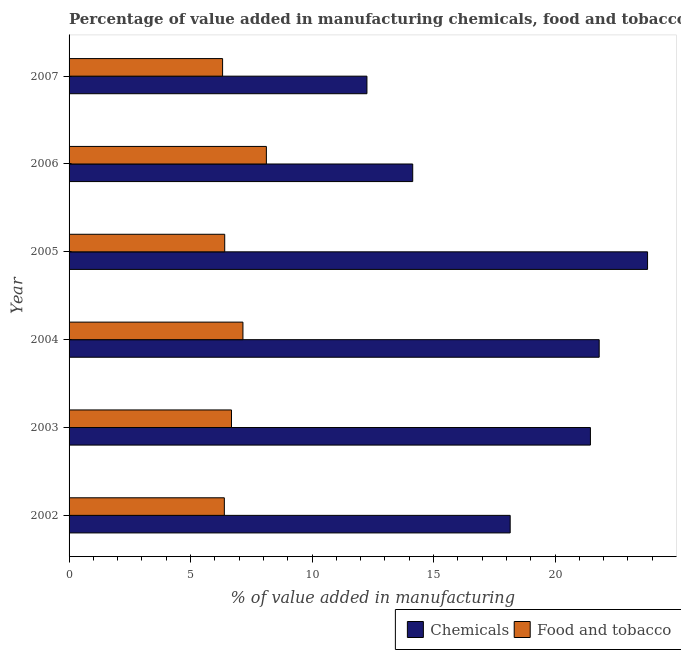How many different coloured bars are there?
Your response must be concise. 2. How many groups of bars are there?
Offer a very short reply. 6. Are the number of bars per tick equal to the number of legend labels?
Keep it short and to the point. Yes. What is the value added by manufacturing food and tobacco in 2006?
Ensure brevity in your answer.  8.12. Across all years, what is the maximum value added by manufacturing food and tobacco?
Your answer should be compact. 8.12. Across all years, what is the minimum value added by manufacturing food and tobacco?
Offer a terse response. 6.32. In which year was the value added by manufacturing food and tobacco minimum?
Offer a terse response. 2007. What is the total value added by manufacturing food and tobacco in the graph?
Your answer should be very brief. 41.07. What is the difference between the value added by manufacturing food and tobacco in 2005 and that in 2007?
Offer a terse response. 0.09. What is the difference between the value added by manufacturing food and tobacco in 2005 and the value added by  manufacturing chemicals in 2003?
Make the answer very short. -15.05. What is the average value added by manufacturing food and tobacco per year?
Provide a succinct answer. 6.84. In the year 2004, what is the difference between the value added by  manufacturing chemicals and value added by manufacturing food and tobacco?
Ensure brevity in your answer.  14.66. What is the ratio of the value added by manufacturing food and tobacco in 2002 to that in 2003?
Offer a very short reply. 0.96. Is the value added by manufacturing food and tobacco in 2002 less than that in 2006?
Make the answer very short. Yes. Is the difference between the value added by  manufacturing chemicals in 2002 and 2006 greater than the difference between the value added by manufacturing food and tobacco in 2002 and 2006?
Make the answer very short. Yes. What is the difference between the highest and the second highest value added by  manufacturing chemicals?
Give a very brief answer. 1.99. What is the difference between the highest and the lowest value added by  manufacturing chemicals?
Your response must be concise. 11.55. In how many years, is the value added by  manufacturing chemicals greater than the average value added by  manufacturing chemicals taken over all years?
Your answer should be very brief. 3. Is the sum of the value added by manufacturing food and tobacco in 2003 and 2004 greater than the maximum value added by  manufacturing chemicals across all years?
Your answer should be compact. No. What does the 1st bar from the top in 2005 represents?
Your answer should be very brief. Food and tobacco. What does the 2nd bar from the bottom in 2006 represents?
Your response must be concise. Food and tobacco. How many bars are there?
Make the answer very short. 12. How many years are there in the graph?
Give a very brief answer. 6. Does the graph contain grids?
Keep it short and to the point. No. Where does the legend appear in the graph?
Keep it short and to the point. Bottom right. What is the title of the graph?
Make the answer very short. Percentage of value added in manufacturing chemicals, food and tobacco in Bahrain. Does "Technicians" appear as one of the legend labels in the graph?
Make the answer very short. No. What is the label or title of the X-axis?
Your answer should be compact. % of value added in manufacturing. What is the % of value added in manufacturing in Chemicals in 2002?
Your response must be concise. 18.15. What is the % of value added in manufacturing of Food and tobacco in 2002?
Provide a short and direct response. 6.39. What is the % of value added in manufacturing in Chemicals in 2003?
Make the answer very short. 21.46. What is the % of value added in manufacturing in Food and tobacco in 2003?
Your response must be concise. 6.68. What is the % of value added in manufacturing of Chemicals in 2004?
Offer a terse response. 21.82. What is the % of value added in manufacturing in Food and tobacco in 2004?
Make the answer very short. 7.16. What is the % of value added in manufacturing in Chemicals in 2005?
Provide a succinct answer. 23.81. What is the % of value added in manufacturing in Food and tobacco in 2005?
Offer a terse response. 6.41. What is the % of value added in manufacturing in Chemicals in 2006?
Give a very brief answer. 14.14. What is the % of value added in manufacturing in Food and tobacco in 2006?
Ensure brevity in your answer.  8.12. What is the % of value added in manufacturing of Chemicals in 2007?
Ensure brevity in your answer.  12.26. What is the % of value added in manufacturing in Food and tobacco in 2007?
Offer a terse response. 6.32. Across all years, what is the maximum % of value added in manufacturing in Chemicals?
Offer a terse response. 23.81. Across all years, what is the maximum % of value added in manufacturing in Food and tobacco?
Your answer should be very brief. 8.12. Across all years, what is the minimum % of value added in manufacturing in Chemicals?
Your answer should be very brief. 12.26. Across all years, what is the minimum % of value added in manufacturing in Food and tobacco?
Your answer should be compact. 6.32. What is the total % of value added in manufacturing of Chemicals in the graph?
Give a very brief answer. 111.63. What is the total % of value added in manufacturing of Food and tobacco in the graph?
Your answer should be compact. 41.07. What is the difference between the % of value added in manufacturing of Chemicals in 2002 and that in 2003?
Provide a short and direct response. -3.3. What is the difference between the % of value added in manufacturing of Food and tobacco in 2002 and that in 2003?
Make the answer very short. -0.29. What is the difference between the % of value added in manufacturing of Chemicals in 2002 and that in 2004?
Ensure brevity in your answer.  -3.66. What is the difference between the % of value added in manufacturing in Food and tobacco in 2002 and that in 2004?
Offer a very short reply. -0.77. What is the difference between the % of value added in manufacturing in Chemicals in 2002 and that in 2005?
Give a very brief answer. -5.65. What is the difference between the % of value added in manufacturing of Food and tobacco in 2002 and that in 2005?
Your response must be concise. -0.01. What is the difference between the % of value added in manufacturing of Chemicals in 2002 and that in 2006?
Provide a short and direct response. 4.01. What is the difference between the % of value added in manufacturing in Food and tobacco in 2002 and that in 2006?
Your answer should be very brief. -1.73. What is the difference between the % of value added in manufacturing of Chemicals in 2002 and that in 2007?
Offer a terse response. 5.89. What is the difference between the % of value added in manufacturing in Food and tobacco in 2002 and that in 2007?
Provide a short and direct response. 0.07. What is the difference between the % of value added in manufacturing in Chemicals in 2003 and that in 2004?
Give a very brief answer. -0.36. What is the difference between the % of value added in manufacturing of Food and tobacco in 2003 and that in 2004?
Keep it short and to the point. -0.47. What is the difference between the % of value added in manufacturing in Chemicals in 2003 and that in 2005?
Make the answer very short. -2.35. What is the difference between the % of value added in manufacturing of Food and tobacco in 2003 and that in 2005?
Ensure brevity in your answer.  0.28. What is the difference between the % of value added in manufacturing of Chemicals in 2003 and that in 2006?
Provide a short and direct response. 7.31. What is the difference between the % of value added in manufacturing in Food and tobacco in 2003 and that in 2006?
Offer a terse response. -1.44. What is the difference between the % of value added in manufacturing of Chemicals in 2003 and that in 2007?
Offer a very short reply. 9.2. What is the difference between the % of value added in manufacturing of Food and tobacco in 2003 and that in 2007?
Offer a very short reply. 0.37. What is the difference between the % of value added in manufacturing in Chemicals in 2004 and that in 2005?
Your answer should be very brief. -1.99. What is the difference between the % of value added in manufacturing in Food and tobacco in 2004 and that in 2005?
Your response must be concise. 0.75. What is the difference between the % of value added in manufacturing in Chemicals in 2004 and that in 2006?
Your answer should be compact. 7.67. What is the difference between the % of value added in manufacturing of Food and tobacco in 2004 and that in 2006?
Your answer should be very brief. -0.96. What is the difference between the % of value added in manufacturing in Chemicals in 2004 and that in 2007?
Ensure brevity in your answer.  9.56. What is the difference between the % of value added in manufacturing in Food and tobacco in 2004 and that in 2007?
Give a very brief answer. 0.84. What is the difference between the % of value added in manufacturing in Chemicals in 2005 and that in 2006?
Keep it short and to the point. 9.66. What is the difference between the % of value added in manufacturing of Food and tobacco in 2005 and that in 2006?
Offer a terse response. -1.71. What is the difference between the % of value added in manufacturing in Chemicals in 2005 and that in 2007?
Offer a very short reply. 11.55. What is the difference between the % of value added in manufacturing in Food and tobacco in 2005 and that in 2007?
Offer a terse response. 0.09. What is the difference between the % of value added in manufacturing of Chemicals in 2006 and that in 2007?
Keep it short and to the point. 1.88. What is the difference between the % of value added in manufacturing of Food and tobacco in 2006 and that in 2007?
Your response must be concise. 1.8. What is the difference between the % of value added in manufacturing in Chemicals in 2002 and the % of value added in manufacturing in Food and tobacco in 2003?
Give a very brief answer. 11.47. What is the difference between the % of value added in manufacturing of Chemicals in 2002 and the % of value added in manufacturing of Food and tobacco in 2004?
Offer a very short reply. 11. What is the difference between the % of value added in manufacturing in Chemicals in 2002 and the % of value added in manufacturing in Food and tobacco in 2005?
Provide a succinct answer. 11.75. What is the difference between the % of value added in manufacturing in Chemicals in 2002 and the % of value added in manufacturing in Food and tobacco in 2006?
Offer a terse response. 10.03. What is the difference between the % of value added in manufacturing in Chemicals in 2002 and the % of value added in manufacturing in Food and tobacco in 2007?
Make the answer very short. 11.84. What is the difference between the % of value added in manufacturing in Chemicals in 2003 and the % of value added in manufacturing in Food and tobacco in 2004?
Offer a very short reply. 14.3. What is the difference between the % of value added in manufacturing of Chemicals in 2003 and the % of value added in manufacturing of Food and tobacco in 2005?
Give a very brief answer. 15.05. What is the difference between the % of value added in manufacturing in Chemicals in 2003 and the % of value added in manufacturing in Food and tobacco in 2006?
Your response must be concise. 13.34. What is the difference between the % of value added in manufacturing of Chemicals in 2003 and the % of value added in manufacturing of Food and tobacco in 2007?
Keep it short and to the point. 15.14. What is the difference between the % of value added in manufacturing in Chemicals in 2004 and the % of value added in manufacturing in Food and tobacco in 2005?
Give a very brief answer. 15.41. What is the difference between the % of value added in manufacturing of Chemicals in 2004 and the % of value added in manufacturing of Food and tobacco in 2006?
Offer a very short reply. 13.7. What is the difference between the % of value added in manufacturing of Chemicals in 2004 and the % of value added in manufacturing of Food and tobacco in 2007?
Ensure brevity in your answer.  15.5. What is the difference between the % of value added in manufacturing of Chemicals in 2005 and the % of value added in manufacturing of Food and tobacco in 2006?
Give a very brief answer. 15.69. What is the difference between the % of value added in manufacturing in Chemicals in 2005 and the % of value added in manufacturing in Food and tobacco in 2007?
Ensure brevity in your answer.  17.49. What is the difference between the % of value added in manufacturing in Chemicals in 2006 and the % of value added in manufacturing in Food and tobacco in 2007?
Ensure brevity in your answer.  7.82. What is the average % of value added in manufacturing of Chemicals per year?
Offer a terse response. 18.61. What is the average % of value added in manufacturing in Food and tobacco per year?
Ensure brevity in your answer.  6.85. In the year 2002, what is the difference between the % of value added in manufacturing in Chemicals and % of value added in manufacturing in Food and tobacco?
Keep it short and to the point. 11.76. In the year 2003, what is the difference between the % of value added in manufacturing in Chemicals and % of value added in manufacturing in Food and tobacco?
Give a very brief answer. 14.77. In the year 2004, what is the difference between the % of value added in manufacturing of Chemicals and % of value added in manufacturing of Food and tobacco?
Provide a succinct answer. 14.66. In the year 2005, what is the difference between the % of value added in manufacturing in Chemicals and % of value added in manufacturing in Food and tobacco?
Offer a very short reply. 17.4. In the year 2006, what is the difference between the % of value added in manufacturing of Chemicals and % of value added in manufacturing of Food and tobacco?
Provide a succinct answer. 6.02. In the year 2007, what is the difference between the % of value added in manufacturing in Chemicals and % of value added in manufacturing in Food and tobacco?
Provide a short and direct response. 5.94. What is the ratio of the % of value added in manufacturing in Chemicals in 2002 to that in 2003?
Offer a terse response. 0.85. What is the ratio of the % of value added in manufacturing of Food and tobacco in 2002 to that in 2003?
Ensure brevity in your answer.  0.96. What is the ratio of the % of value added in manufacturing in Chemicals in 2002 to that in 2004?
Provide a short and direct response. 0.83. What is the ratio of the % of value added in manufacturing of Food and tobacco in 2002 to that in 2004?
Give a very brief answer. 0.89. What is the ratio of the % of value added in manufacturing of Chemicals in 2002 to that in 2005?
Keep it short and to the point. 0.76. What is the ratio of the % of value added in manufacturing of Chemicals in 2002 to that in 2006?
Give a very brief answer. 1.28. What is the ratio of the % of value added in manufacturing of Food and tobacco in 2002 to that in 2006?
Offer a terse response. 0.79. What is the ratio of the % of value added in manufacturing in Chemicals in 2002 to that in 2007?
Give a very brief answer. 1.48. What is the ratio of the % of value added in manufacturing in Food and tobacco in 2002 to that in 2007?
Keep it short and to the point. 1.01. What is the ratio of the % of value added in manufacturing in Chemicals in 2003 to that in 2004?
Provide a succinct answer. 0.98. What is the ratio of the % of value added in manufacturing in Food and tobacco in 2003 to that in 2004?
Keep it short and to the point. 0.93. What is the ratio of the % of value added in manufacturing in Chemicals in 2003 to that in 2005?
Provide a short and direct response. 0.9. What is the ratio of the % of value added in manufacturing of Food and tobacco in 2003 to that in 2005?
Provide a short and direct response. 1.04. What is the ratio of the % of value added in manufacturing of Chemicals in 2003 to that in 2006?
Provide a succinct answer. 1.52. What is the ratio of the % of value added in manufacturing of Food and tobacco in 2003 to that in 2006?
Provide a short and direct response. 0.82. What is the ratio of the % of value added in manufacturing in Chemicals in 2003 to that in 2007?
Ensure brevity in your answer.  1.75. What is the ratio of the % of value added in manufacturing of Food and tobacco in 2003 to that in 2007?
Provide a succinct answer. 1.06. What is the ratio of the % of value added in manufacturing of Chemicals in 2004 to that in 2005?
Keep it short and to the point. 0.92. What is the ratio of the % of value added in manufacturing of Food and tobacco in 2004 to that in 2005?
Ensure brevity in your answer.  1.12. What is the ratio of the % of value added in manufacturing in Chemicals in 2004 to that in 2006?
Your answer should be very brief. 1.54. What is the ratio of the % of value added in manufacturing in Food and tobacco in 2004 to that in 2006?
Provide a succinct answer. 0.88. What is the ratio of the % of value added in manufacturing of Chemicals in 2004 to that in 2007?
Your answer should be very brief. 1.78. What is the ratio of the % of value added in manufacturing in Food and tobacco in 2004 to that in 2007?
Make the answer very short. 1.13. What is the ratio of the % of value added in manufacturing in Chemicals in 2005 to that in 2006?
Give a very brief answer. 1.68. What is the ratio of the % of value added in manufacturing in Food and tobacco in 2005 to that in 2006?
Keep it short and to the point. 0.79. What is the ratio of the % of value added in manufacturing of Chemicals in 2005 to that in 2007?
Offer a very short reply. 1.94. What is the ratio of the % of value added in manufacturing of Food and tobacco in 2005 to that in 2007?
Your answer should be compact. 1.01. What is the ratio of the % of value added in manufacturing of Chemicals in 2006 to that in 2007?
Provide a succinct answer. 1.15. What is the ratio of the % of value added in manufacturing of Food and tobacco in 2006 to that in 2007?
Your response must be concise. 1.29. What is the difference between the highest and the second highest % of value added in manufacturing in Chemicals?
Offer a very short reply. 1.99. What is the difference between the highest and the second highest % of value added in manufacturing of Food and tobacco?
Make the answer very short. 0.96. What is the difference between the highest and the lowest % of value added in manufacturing of Chemicals?
Provide a succinct answer. 11.55. What is the difference between the highest and the lowest % of value added in manufacturing in Food and tobacco?
Ensure brevity in your answer.  1.8. 